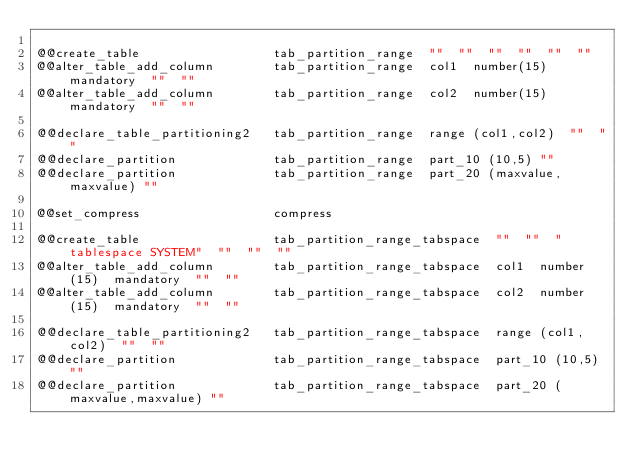<code> <loc_0><loc_0><loc_500><loc_500><_SQL_>
@@create_table                  tab_partition_range  ""  ""  ""  ""  ""  ""
@@alter_table_add_column        tab_partition_range  col1  number(15)  mandatory  ""  ""
@@alter_table_add_column        tab_partition_range  col2  number(15)  mandatory  ""  ""

@@declare_table_partitioning2   tab_partition_range  range (col1,col2)  ""  "" 
@@declare_partition             tab_partition_range  part_10 (10,5) ""
@@declare_partition             tab_partition_range  part_20 (maxvalue,maxvalue) ""

@@set_compress                  compress

@@create_table                  tab_partition_range_tabspace  ""  ""  "tablespace SYSTEM"  ""  ""  ""
@@alter_table_add_column        tab_partition_range_tabspace  col1  number(15)  mandatory  ""  ""
@@alter_table_add_column        tab_partition_range_tabspace  col2  number(15)  mandatory  ""  ""

@@declare_table_partitioning2   tab_partition_range_tabspace  range (col1,col2)  ""  "" 
@@declare_partition             tab_partition_range_tabspace  part_10 (10,5) ""
@@declare_partition             tab_partition_range_tabspace  part_20 (maxvalue,maxvalue) ""








</code> 